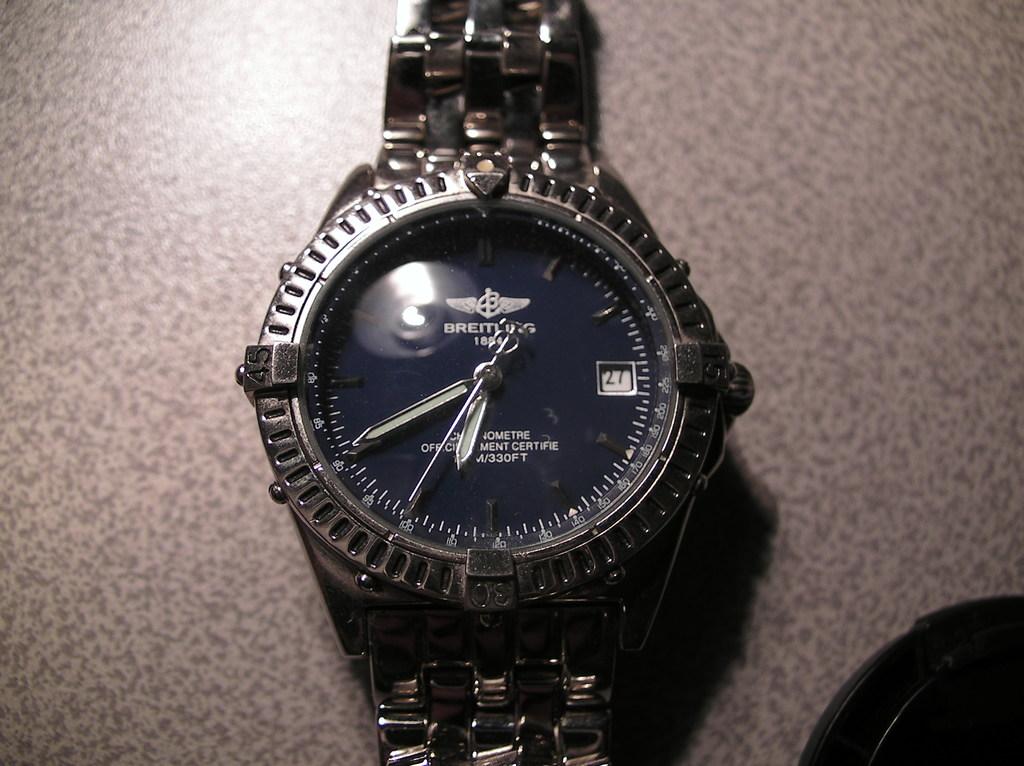What time is shown?
Provide a short and direct response. 6:40. What kind it is?
Give a very brief answer. Breitling. 